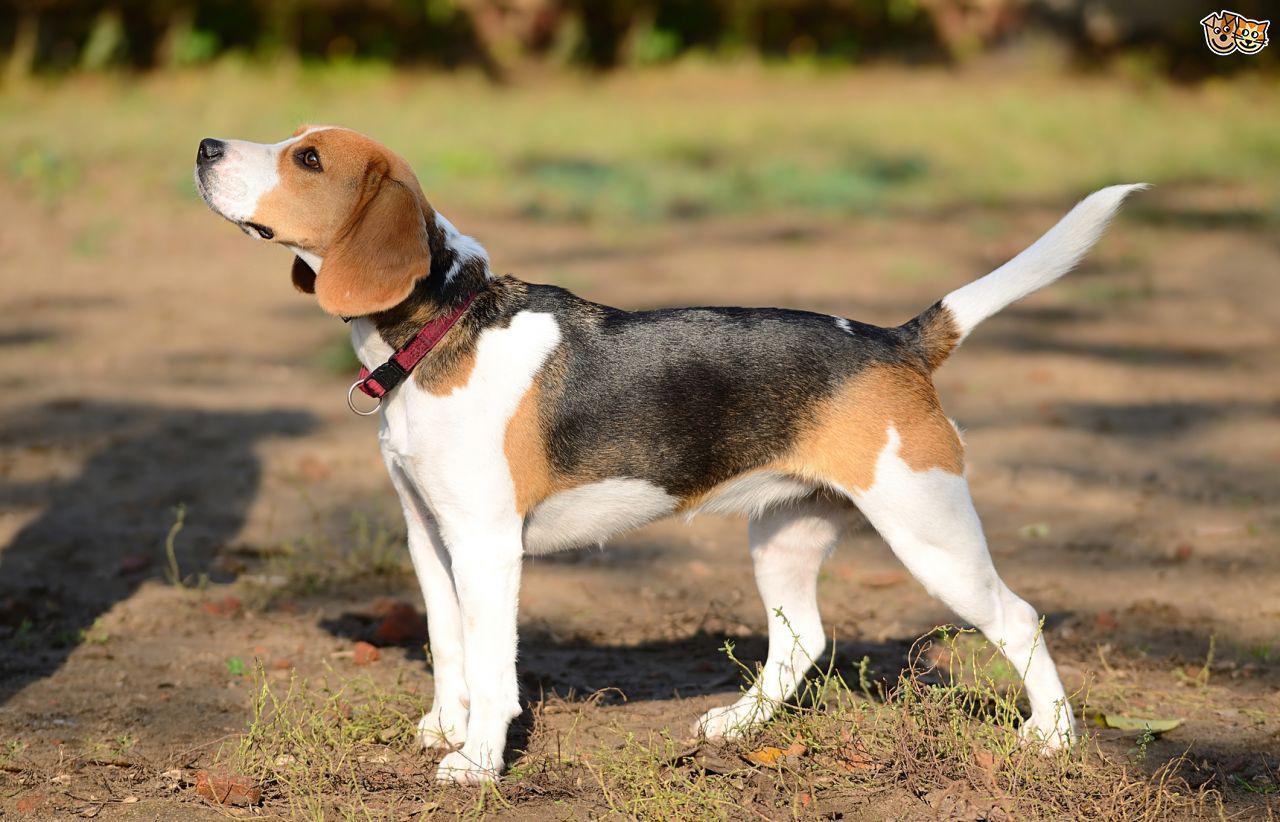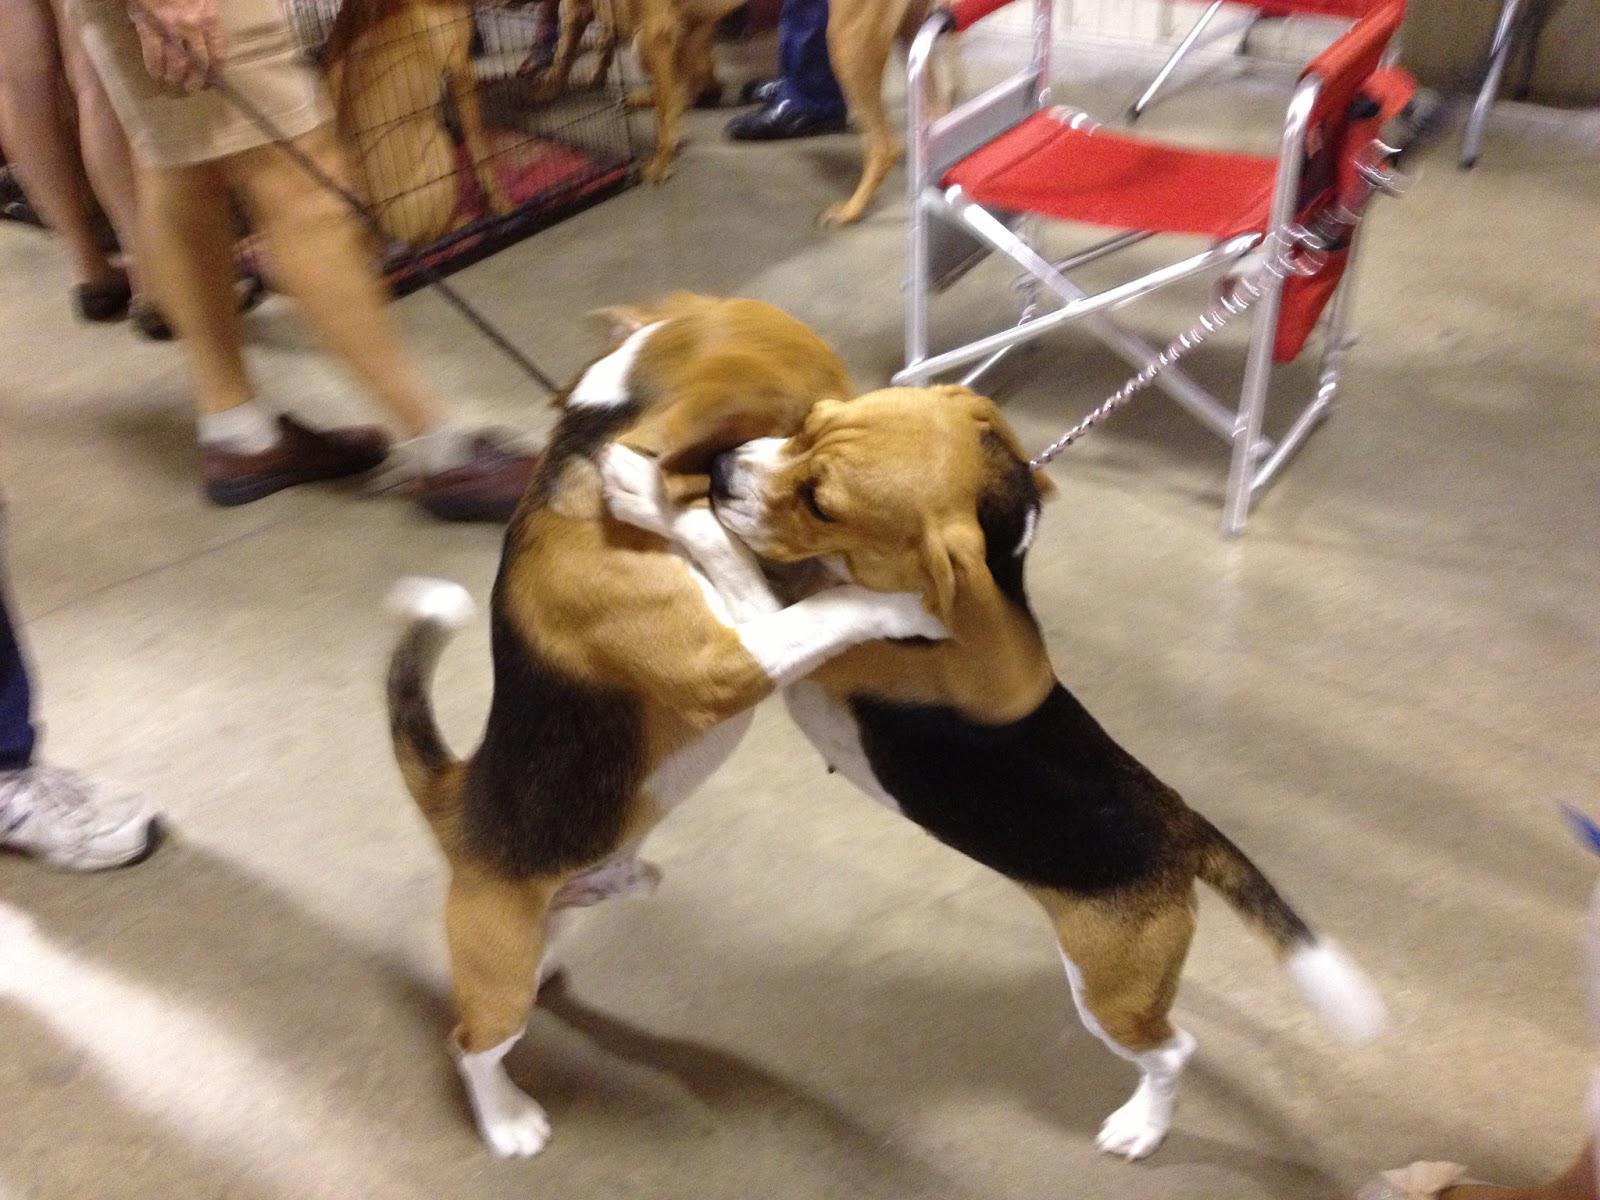The first image is the image on the left, the second image is the image on the right. Assess this claim about the two images: "There are no more than two dogs.". Correct or not? Answer yes or no. No. The first image is the image on the left, the second image is the image on the right. Considering the images on both sides, is "An image includes two tri-color beagles of the same approximate size." valid? Answer yes or no. Yes. 